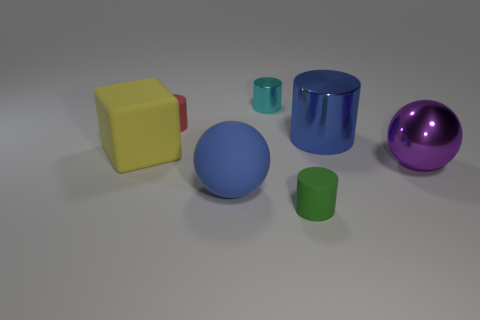Do the sphere in front of the purple metallic ball and the cylinder that is in front of the purple metallic object have the same size?
Offer a terse response. No. What number of other small red objects have the same material as the small red thing?
Your response must be concise. 0. There is a small object in front of the small matte cylinder to the left of the tiny cyan metallic thing; how many large blue cylinders are to the right of it?
Your response must be concise. 1. Does the tiny green object have the same shape as the big yellow matte object?
Ensure brevity in your answer.  No. Are there any other red matte things of the same shape as the red rubber object?
Give a very brief answer. No. What shape is the other matte thing that is the same size as the green thing?
Your answer should be very brief. Cylinder. What is the block in front of the rubber cylinder behind the cylinder in front of the blue metal object made of?
Ensure brevity in your answer.  Rubber. Do the yellow object and the purple metallic thing have the same size?
Provide a short and direct response. Yes. What material is the big cylinder?
Make the answer very short. Metal. There is a object that is the same color as the big matte sphere; what is it made of?
Provide a succinct answer. Metal. 